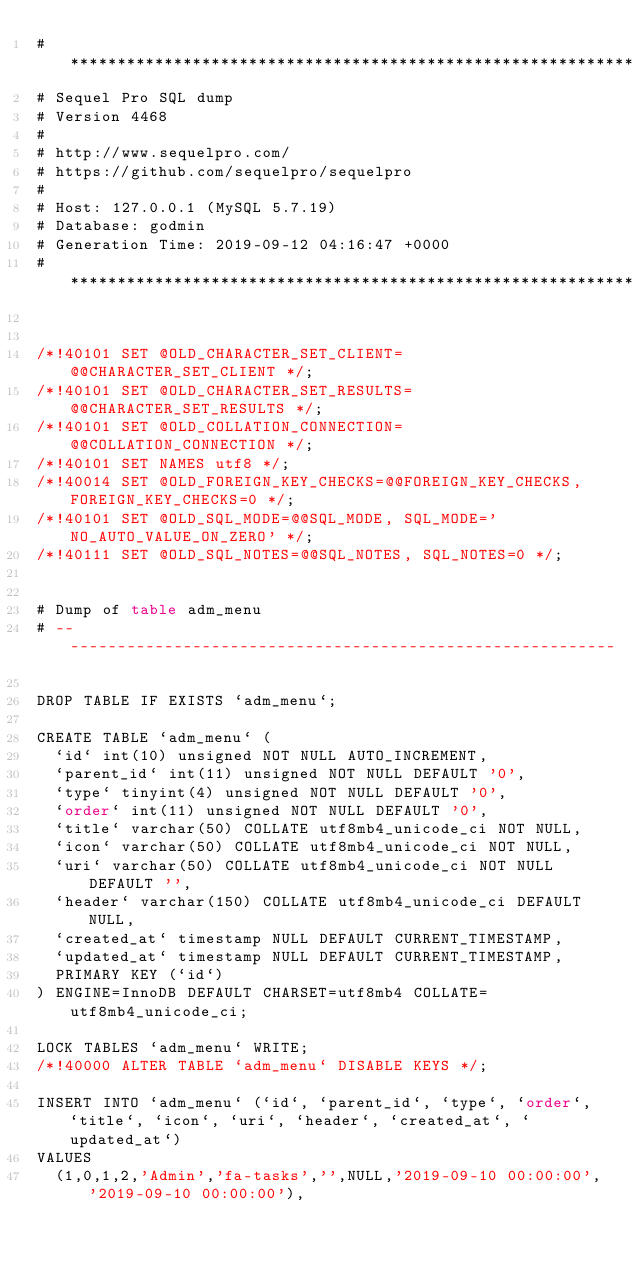<code> <loc_0><loc_0><loc_500><loc_500><_SQL_># ************************************************************
# Sequel Pro SQL dump
# Version 4468
#
# http://www.sequelpro.com/
# https://github.com/sequelpro/sequelpro
#
# Host: 127.0.0.1 (MySQL 5.7.19)
# Database: godmin
# Generation Time: 2019-09-12 04:16:47 +0000
# ************************************************************


/*!40101 SET @OLD_CHARACTER_SET_CLIENT=@@CHARACTER_SET_CLIENT */;
/*!40101 SET @OLD_CHARACTER_SET_RESULTS=@@CHARACTER_SET_RESULTS */;
/*!40101 SET @OLD_COLLATION_CONNECTION=@@COLLATION_CONNECTION */;
/*!40101 SET NAMES utf8 */;
/*!40014 SET @OLD_FOREIGN_KEY_CHECKS=@@FOREIGN_KEY_CHECKS, FOREIGN_KEY_CHECKS=0 */;
/*!40101 SET @OLD_SQL_MODE=@@SQL_MODE, SQL_MODE='NO_AUTO_VALUE_ON_ZERO' */;
/*!40111 SET @OLD_SQL_NOTES=@@SQL_NOTES, SQL_NOTES=0 */;


# Dump of table adm_menu
# ------------------------------------------------------------

DROP TABLE IF EXISTS `adm_menu`;

CREATE TABLE `adm_menu` (
  `id` int(10) unsigned NOT NULL AUTO_INCREMENT,
  `parent_id` int(11) unsigned NOT NULL DEFAULT '0',
  `type` tinyint(4) unsigned NOT NULL DEFAULT '0',
  `order` int(11) unsigned NOT NULL DEFAULT '0',
  `title` varchar(50) COLLATE utf8mb4_unicode_ci NOT NULL,
  `icon` varchar(50) COLLATE utf8mb4_unicode_ci NOT NULL,
  `uri` varchar(50) COLLATE utf8mb4_unicode_ci NOT NULL DEFAULT '',
  `header` varchar(150) COLLATE utf8mb4_unicode_ci DEFAULT NULL,
  `created_at` timestamp NULL DEFAULT CURRENT_TIMESTAMP,
  `updated_at` timestamp NULL DEFAULT CURRENT_TIMESTAMP,
  PRIMARY KEY (`id`)
) ENGINE=InnoDB DEFAULT CHARSET=utf8mb4 COLLATE=utf8mb4_unicode_ci;

LOCK TABLES `adm_menu` WRITE;
/*!40000 ALTER TABLE `adm_menu` DISABLE KEYS */;

INSERT INTO `adm_menu` (`id`, `parent_id`, `type`, `order`, `title`, `icon`, `uri`, `header`, `created_at`, `updated_at`)
VALUES
	(1,0,1,2,'Admin','fa-tasks','',NULL,'2019-09-10 00:00:00','2019-09-10 00:00:00'),</code> 